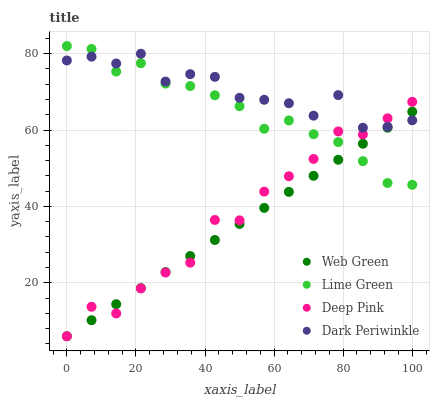Does Web Green have the minimum area under the curve?
Answer yes or no. Yes. Does Dark Periwinkle have the maximum area under the curve?
Answer yes or no. Yes. Does Lime Green have the minimum area under the curve?
Answer yes or no. No. Does Lime Green have the maximum area under the curve?
Answer yes or no. No. Is Web Green the smoothest?
Answer yes or no. Yes. Is Dark Periwinkle the roughest?
Answer yes or no. Yes. Is Lime Green the smoothest?
Answer yes or no. No. Is Lime Green the roughest?
Answer yes or no. No. Does Deep Pink have the lowest value?
Answer yes or no. Yes. Does Lime Green have the lowest value?
Answer yes or no. No. Does Lime Green have the highest value?
Answer yes or no. Yes. Does Dark Periwinkle have the highest value?
Answer yes or no. No. Does Dark Periwinkle intersect Lime Green?
Answer yes or no. Yes. Is Dark Periwinkle less than Lime Green?
Answer yes or no. No. Is Dark Periwinkle greater than Lime Green?
Answer yes or no. No. 